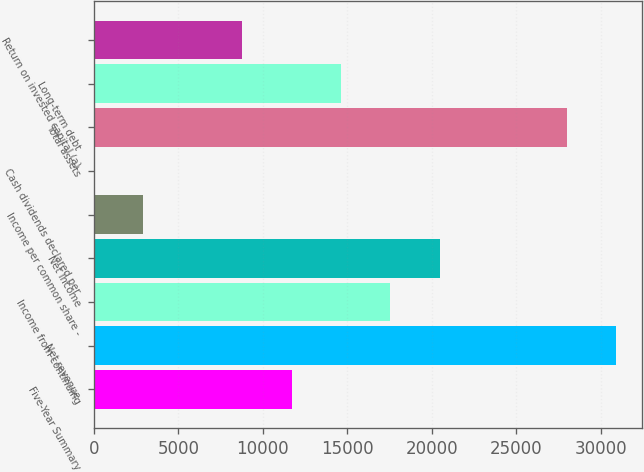Convert chart to OTSL. <chart><loc_0><loc_0><loc_500><loc_500><bar_chart><fcel>Five-Year Summary<fcel>Net revenue<fcel>Income from continuing<fcel>Net income<fcel>Income per common share -<fcel>Cash dividends declared per<fcel>Total assets<fcel>Long-term debt<fcel>Return on invested capital (a)<nl><fcel>11704.9<fcel>30913<fcel>17557<fcel>20483<fcel>2926.87<fcel>0.85<fcel>27987<fcel>14630.9<fcel>8778.91<nl></chart> 